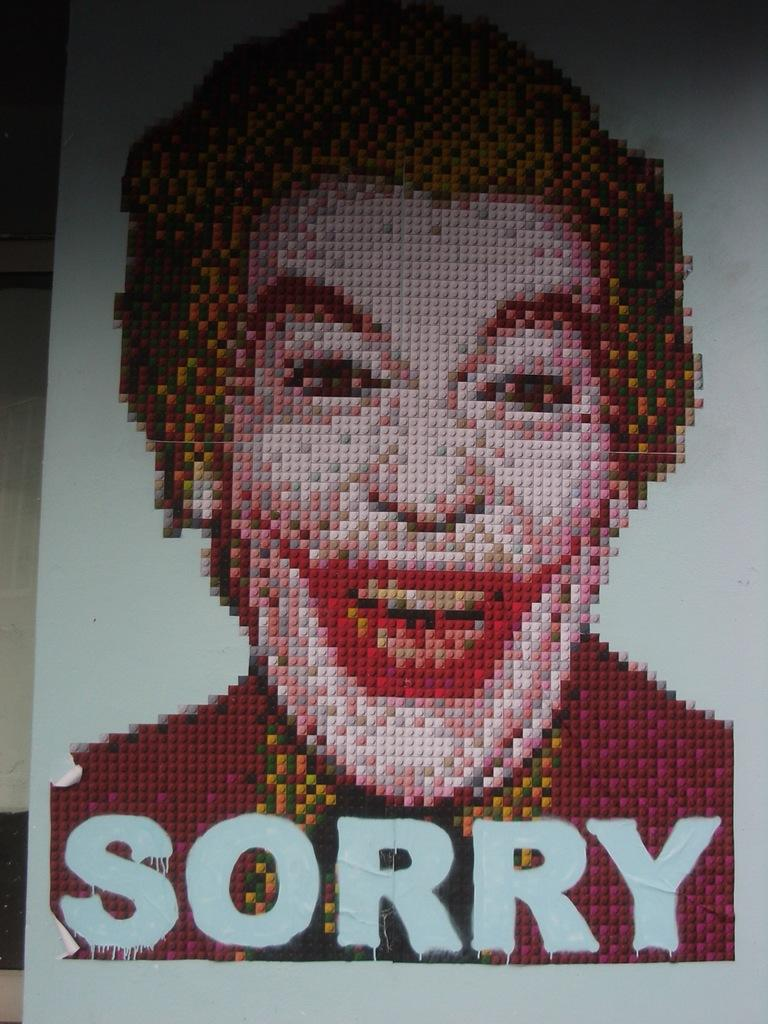What is the main object in the image? There is a board in the image. Who or what is in the center of the image? There is a man in the center of the image. What can be found at the bottom of the image? There is text at the bottom of the image. What type of produce is being sold on the board in the image? There is no produce visible on the board in the image. What material is the brass used for in the image? There is no brass present in the image. 